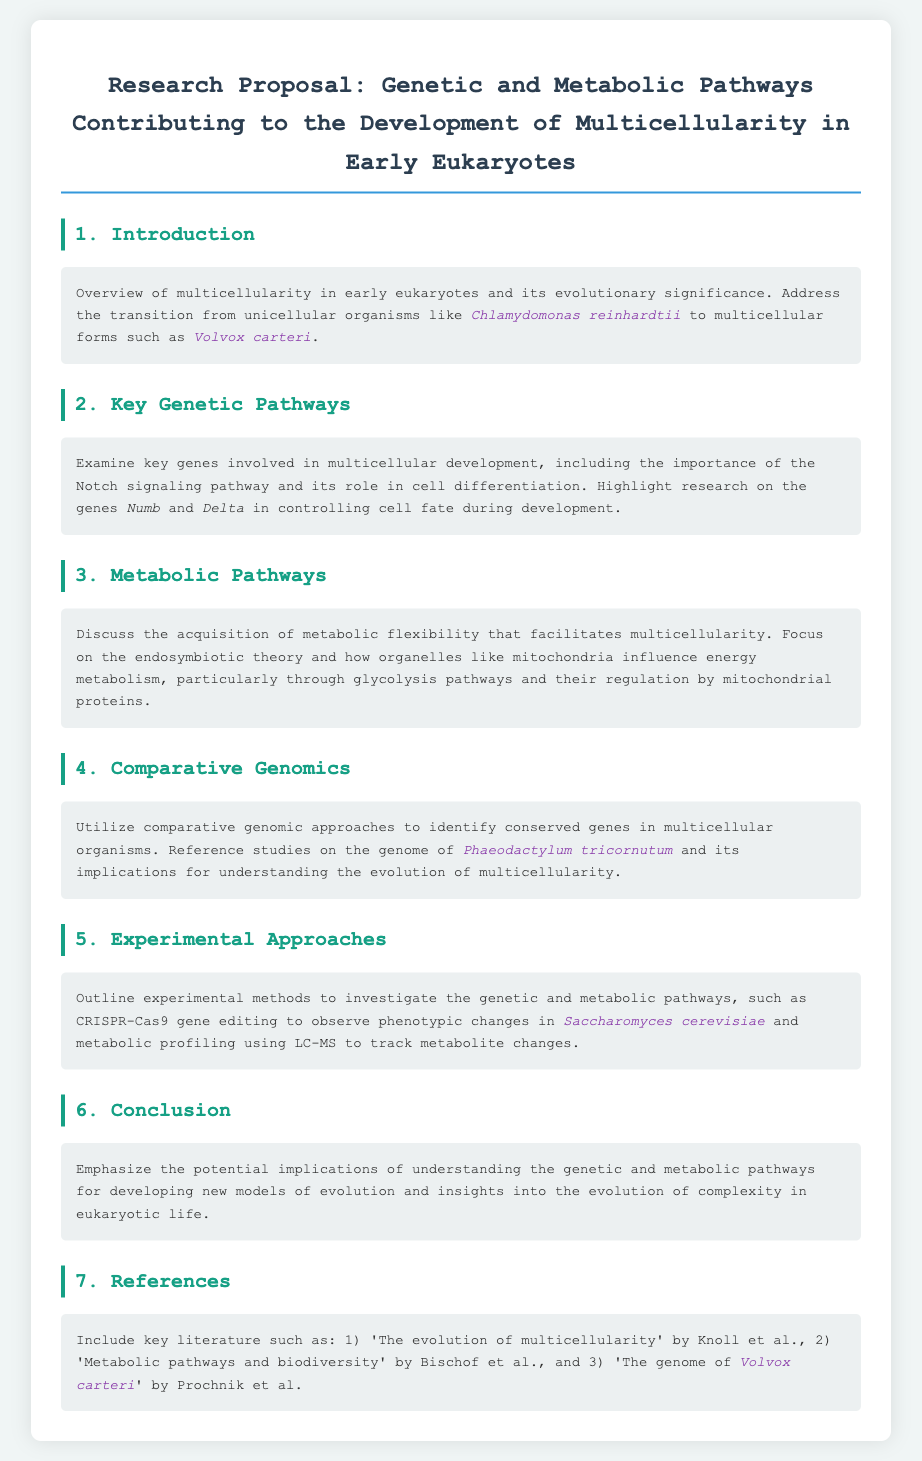What is the primary focus of the research proposal? The primary focus is on genetic and metabolic pathways contributing to multicellularity in early eukaryotes.
Answer: genetic and metabolic pathways contributing to multicellularity in early eukaryotes Which organisms are referenced as examples of unicellular and multicellular forms? Unicellular and multicellular examples are specified within the introduction section of the document.
Answer: Chlamydomonas reinhardtii and Volvox carteri What key signaling pathway is highlighted for its role in cell differentiation? The document mentions a specific signaling pathway instrumental for cell differentiation.
Answer: Notch signaling pathway What experimental method is proposed for observing phenotypic changes? A specific experimental technique is detailed in the experimental approaches section pertaining to observing phenotypic changes.
Answer: CRISPR-Cas9 gene editing Which organism's genome is referenced for understanding multicellularity? The comparative genomics section mentions a particular organism's genome relevant to the study of multicellularity.
Answer: Phaeodactylum tricornutum What type of profiling is suggested for tracking metabolite changes? The document discusses a specific technique for analyzing metabolic changes in organisms.
Answer: LC-MS Who are the authors of the literature included in the references? The references section specifies notable authors tied to key literature on the topic of multicellularity.
Answer: Knoll, Bischof, Prochnik 